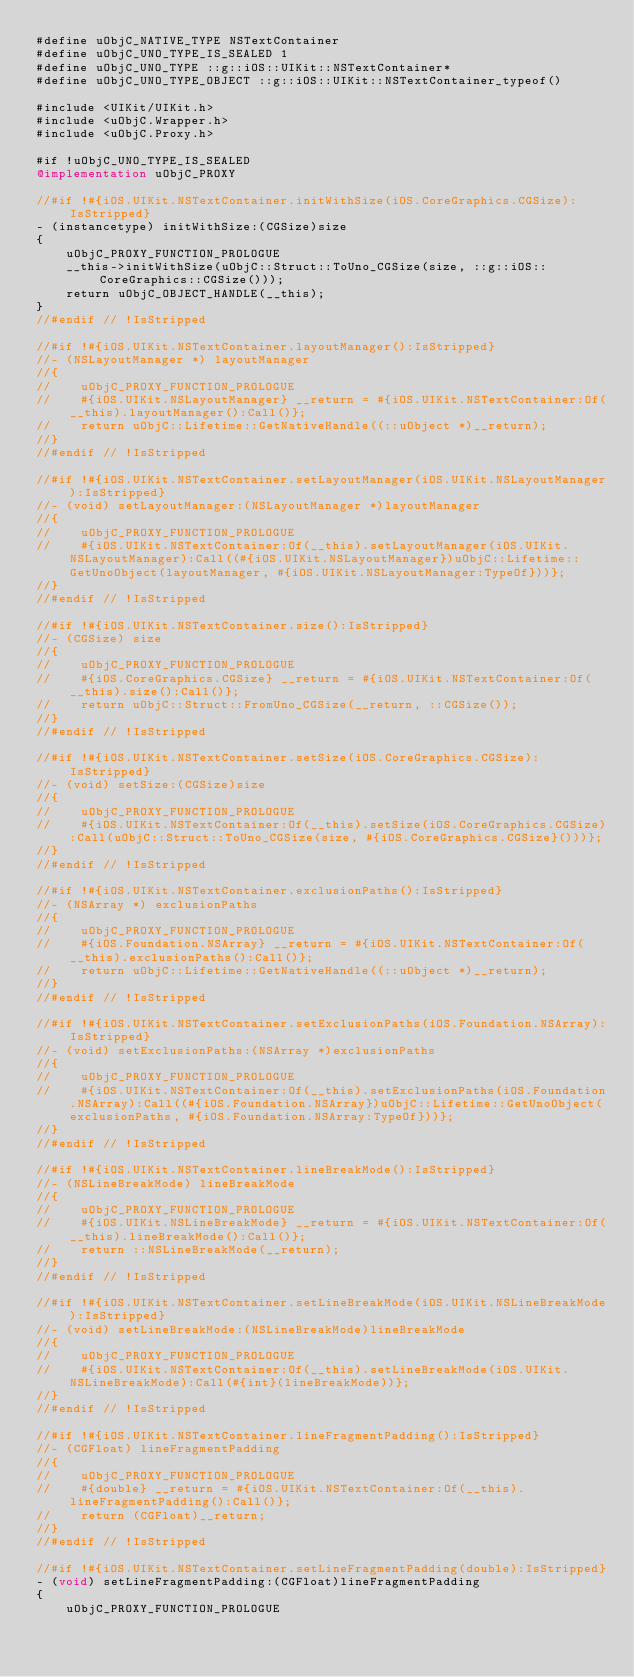Convert code to text. <code><loc_0><loc_0><loc_500><loc_500><_ObjectiveC_>#define uObjC_NATIVE_TYPE NSTextContainer
#define uObjC_UNO_TYPE_IS_SEALED 1
#define uObjC_UNO_TYPE ::g::iOS::UIKit::NSTextContainer*
#define uObjC_UNO_TYPE_OBJECT ::g::iOS::UIKit::NSTextContainer_typeof()

#include <UIKit/UIKit.h>
#include <uObjC.Wrapper.h>
#include <uObjC.Proxy.h>

#if !uObjC_UNO_TYPE_IS_SEALED
@implementation uObjC_PROXY

//#if !#{iOS.UIKit.NSTextContainer.initWithSize(iOS.CoreGraphics.CGSize):IsStripped}
- (instancetype) initWithSize:(CGSize)size
{
    uObjC_PROXY_FUNCTION_PROLOGUE
    __this->initWithSize(uObjC::Struct::ToUno_CGSize(size, ::g::iOS::CoreGraphics::CGSize()));
    return uObjC_OBJECT_HANDLE(__this);
}
//#endif // !IsStripped

//#if !#{iOS.UIKit.NSTextContainer.layoutManager():IsStripped}
//- (NSLayoutManager *) layoutManager
//{
//    uObjC_PROXY_FUNCTION_PROLOGUE
//    #{iOS.UIKit.NSLayoutManager} __return = #{iOS.UIKit.NSTextContainer:Of(__this).layoutManager():Call()};
//    return uObjC::Lifetime::GetNativeHandle((::uObject *)__return);
//}
//#endif // !IsStripped

//#if !#{iOS.UIKit.NSTextContainer.setLayoutManager(iOS.UIKit.NSLayoutManager):IsStripped}
//- (void) setLayoutManager:(NSLayoutManager *)layoutManager
//{
//    uObjC_PROXY_FUNCTION_PROLOGUE
//    #{iOS.UIKit.NSTextContainer:Of(__this).setLayoutManager(iOS.UIKit.NSLayoutManager):Call((#{iOS.UIKit.NSLayoutManager})uObjC::Lifetime::GetUnoObject(layoutManager, #{iOS.UIKit.NSLayoutManager:TypeOf}))};
//}
//#endif // !IsStripped

//#if !#{iOS.UIKit.NSTextContainer.size():IsStripped}
//- (CGSize) size
//{
//    uObjC_PROXY_FUNCTION_PROLOGUE
//    #{iOS.CoreGraphics.CGSize} __return = #{iOS.UIKit.NSTextContainer:Of(__this).size():Call()};
//    return uObjC::Struct::FromUno_CGSize(__return, ::CGSize());
//}
//#endif // !IsStripped

//#if !#{iOS.UIKit.NSTextContainer.setSize(iOS.CoreGraphics.CGSize):IsStripped}
//- (void) setSize:(CGSize)size
//{
//    uObjC_PROXY_FUNCTION_PROLOGUE
//    #{iOS.UIKit.NSTextContainer:Of(__this).setSize(iOS.CoreGraphics.CGSize):Call(uObjC::Struct::ToUno_CGSize(size, #{iOS.CoreGraphics.CGSize}()))};
//}
//#endif // !IsStripped

//#if !#{iOS.UIKit.NSTextContainer.exclusionPaths():IsStripped}
//- (NSArray *) exclusionPaths
//{
//    uObjC_PROXY_FUNCTION_PROLOGUE
//    #{iOS.Foundation.NSArray} __return = #{iOS.UIKit.NSTextContainer:Of(__this).exclusionPaths():Call()};
//    return uObjC::Lifetime::GetNativeHandle((::uObject *)__return);
//}
//#endif // !IsStripped

//#if !#{iOS.UIKit.NSTextContainer.setExclusionPaths(iOS.Foundation.NSArray):IsStripped}
//- (void) setExclusionPaths:(NSArray *)exclusionPaths
//{
//    uObjC_PROXY_FUNCTION_PROLOGUE
//    #{iOS.UIKit.NSTextContainer:Of(__this).setExclusionPaths(iOS.Foundation.NSArray):Call((#{iOS.Foundation.NSArray})uObjC::Lifetime::GetUnoObject(exclusionPaths, #{iOS.Foundation.NSArray:TypeOf}))};
//}
//#endif // !IsStripped

//#if !#{iOS.UIKit.NSTextContainer.lineBreakMode():IsStripped}
//- (NSLineBreakMode) lineBreakMode
//{
//    uObjC_PROXY_FUNCTION_PROLOGUE
//    #{iOS.UIKit.NSLineBreakMode} __return = #{iOS.UIKit.NSTextContainer:Of(__this).lineBreakMode():Call()};
//    return ::NSLineBreakMode(__return);
//}
//#endif // !IsStripped

//#if !#{iOS.UIKit.NSTextContainer.setLineBreakMode(iOS.UIKit.NSLineBreakMode):IsStripped}
//- (void) setLineBreakMode:(NSLineBreakMode)lineBreakMode
//{
//    uObjC_PROXY_FUNCTION_PROLOGUE
//    #{iOS.UIKit.NSTextContainer:Of(__this).setLineBreakMode(iOS.UIKit.NSLineBreakMode):Call(#{int}(lineBreakMode))};
//}
//#endif // !IsStripped

//#if !#{iOS.UIKit.NSTextContainer.lineFragmentPadding():IsStripped}
//- (CGFloat) lineFragmentPadding
//{
//    uObjC_PROXY_FUNCTION_PROLOGUE
//    #{double} __return = #{iOS.UIKit.NSTextContainer:Of(__this).lineFragmentPadding():Call()};
//    return (CGFloat)__return;
//}
//#endif // !IsStripped

//#if !#{iOS.UIKit.NSTextContainer.setLineFragmentPadding(double):IsStripped}
- (void) setLineFragmentPadding:(CGFloat)lineFragmentPadding
{
    uObjC_PROXY_FUNCTION_PROLOGUE</code> 